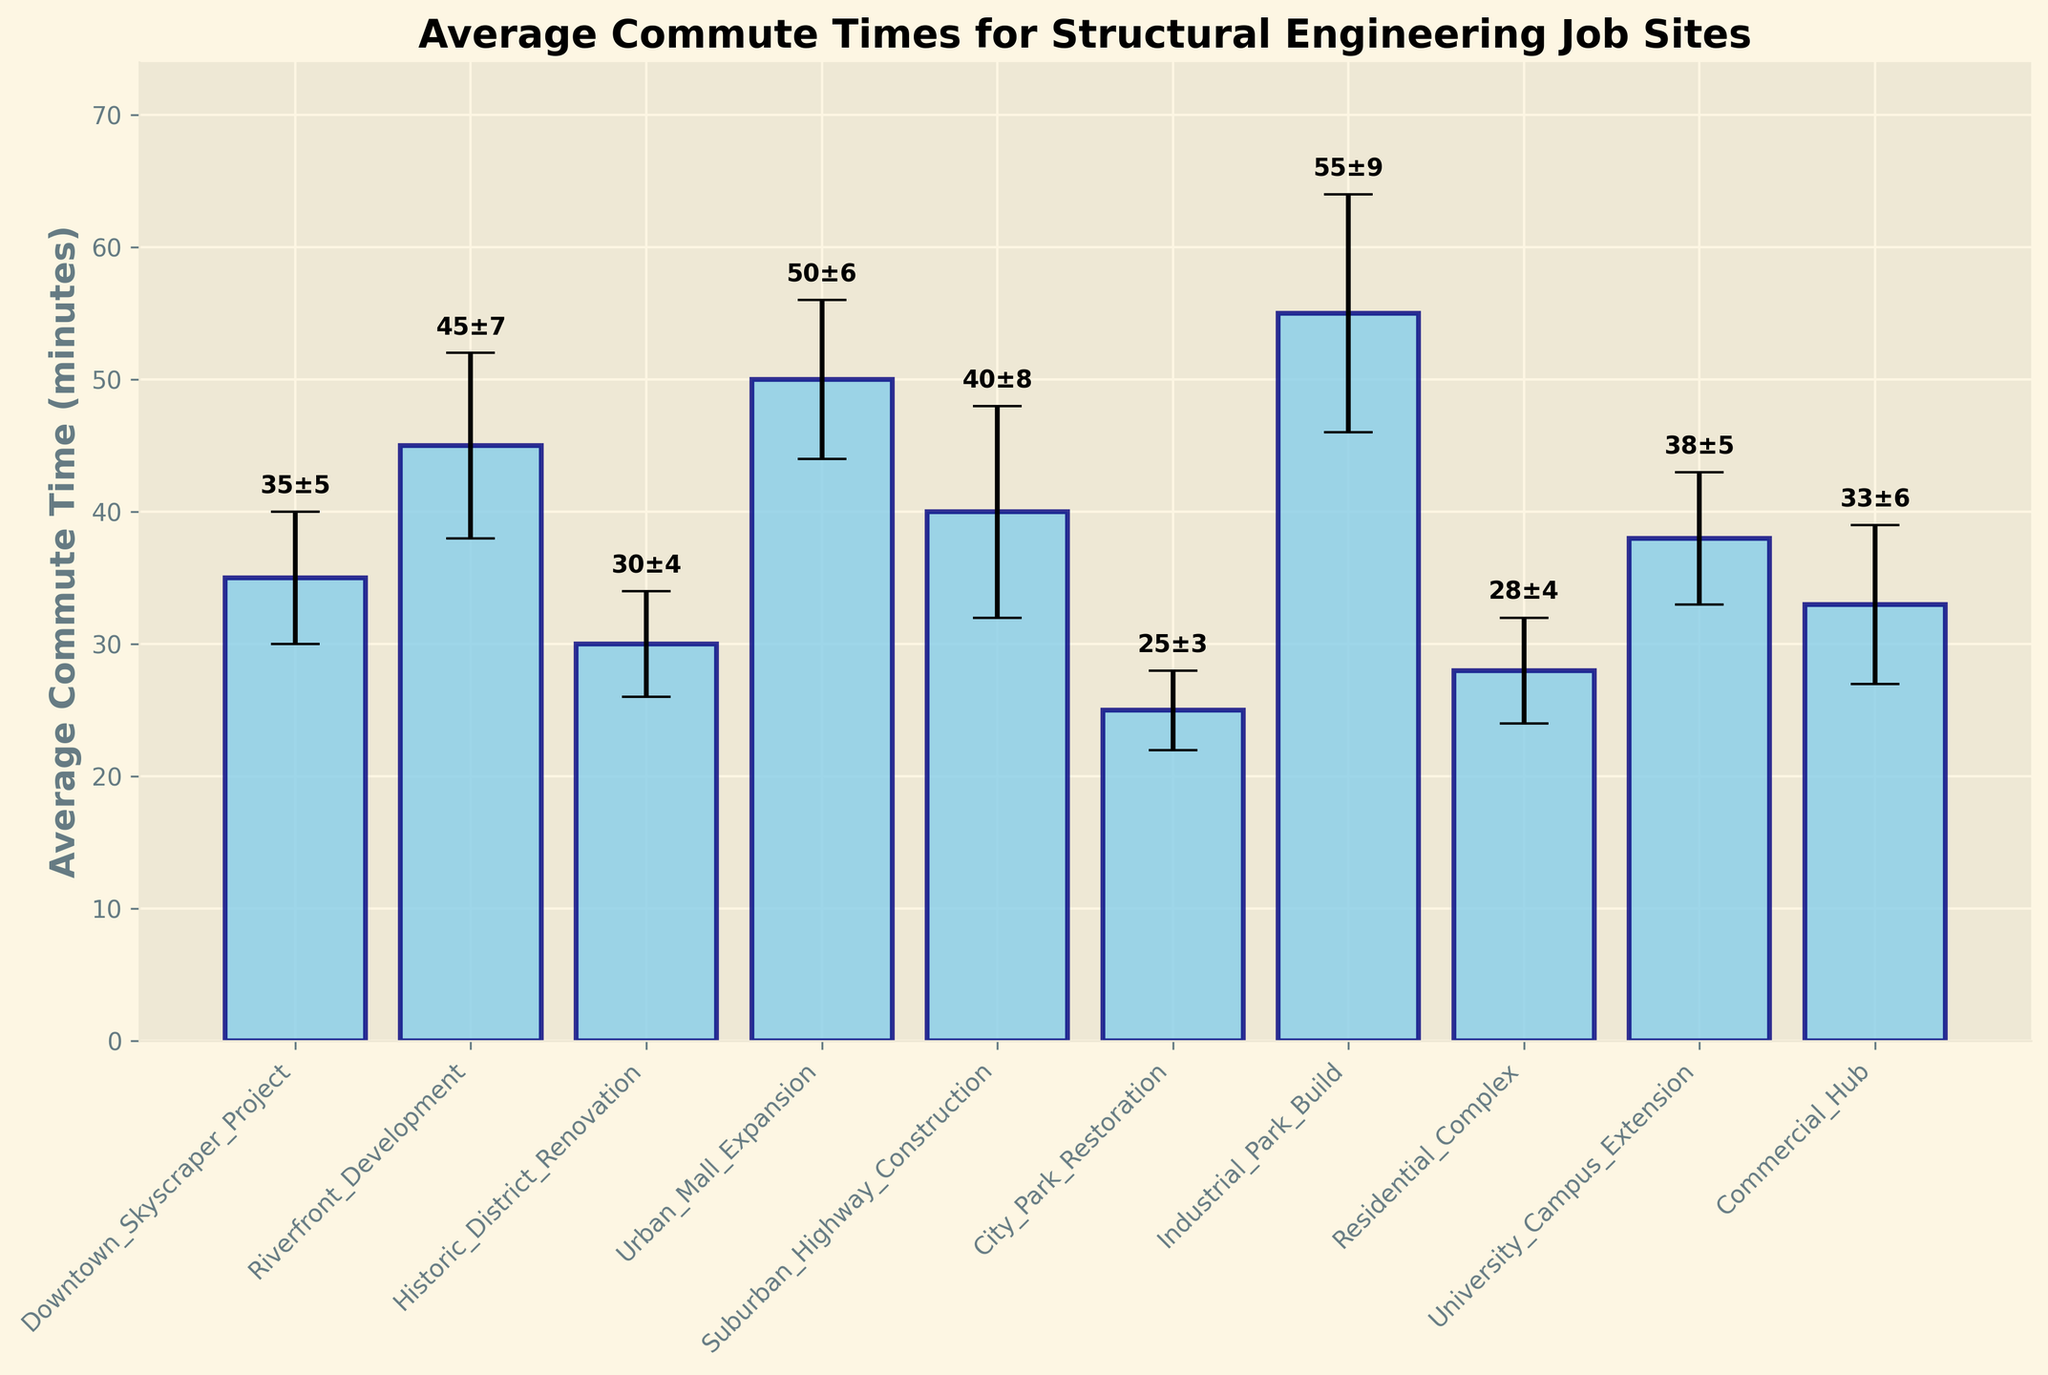Which job site has the highest average commute time? Identify the tallest bar in the figure, which corresponds to the Industrial Park Build job site.
Answer: Industrial Park Build How much more is the average commute time for the Urban Mall Expansion compared to the City Park Restoration? Look at the heights of the bars for Urban Mall Expansion and City Park Restoration. Urban Mall Expansion has an average commute time of 50 minutes, while City Park Restoration is 25 minutes. The difference is 50 - 25.
Answer: 25 minutes Which job site has the lowest standard deviation in commute times? Compare the error bars (vertical lines) across all job sites. The City Park Restoration has the smallest error bar (3 minutes).
Answer: City Park Restoration What is the average commute time for the Downtown Skyscraper Project, and what are its error margins? Locate the Downtown Skyscraper Project bar. The label shows an average of 35 minutes, with an error margin of ±5 minutes.
Answer: 35±5 minutes What is the range of average commute times for all the job sites? Identify the lowest and highest values of the bars. The lowest average is 25 minutes (City Park Restoration), and the highest is 55 minutes (Industrial Park Build). The range is 55 - 25.
Answer: 30 minutes Which two job sites have the closest average commute times? Compare the values of the average commute times for all job sites and identify which two are closest. The Downtown Skyscraper Project and University Campus Extension both have averages of 35 and 38 minutes, respectively.
Answer: Downtown Skyscraper Project and University Campus Extension What is the total average commute time for the Residential Complex and University Campus Extension combined? Sum the average commute times for the Residential Complex and University Campus Extension. Residential Complex has 28 minutes, and University Campus Extension has 38 minutes. 28 + 38 = 66 minutes.
Answer: 66 minutes How does the standard deviation of the commute time for Suburban Highway Construction compare to Historic District Renovation? Look at the error bars for both job sites. Suburban Highway Construction has 8 minutes, and Historic District Renovation has 4 minutes. 8 - 4 = 4 minutes difference. Suburban Highway Construction has a larger deviation.
Answer: 4 minutes larger 